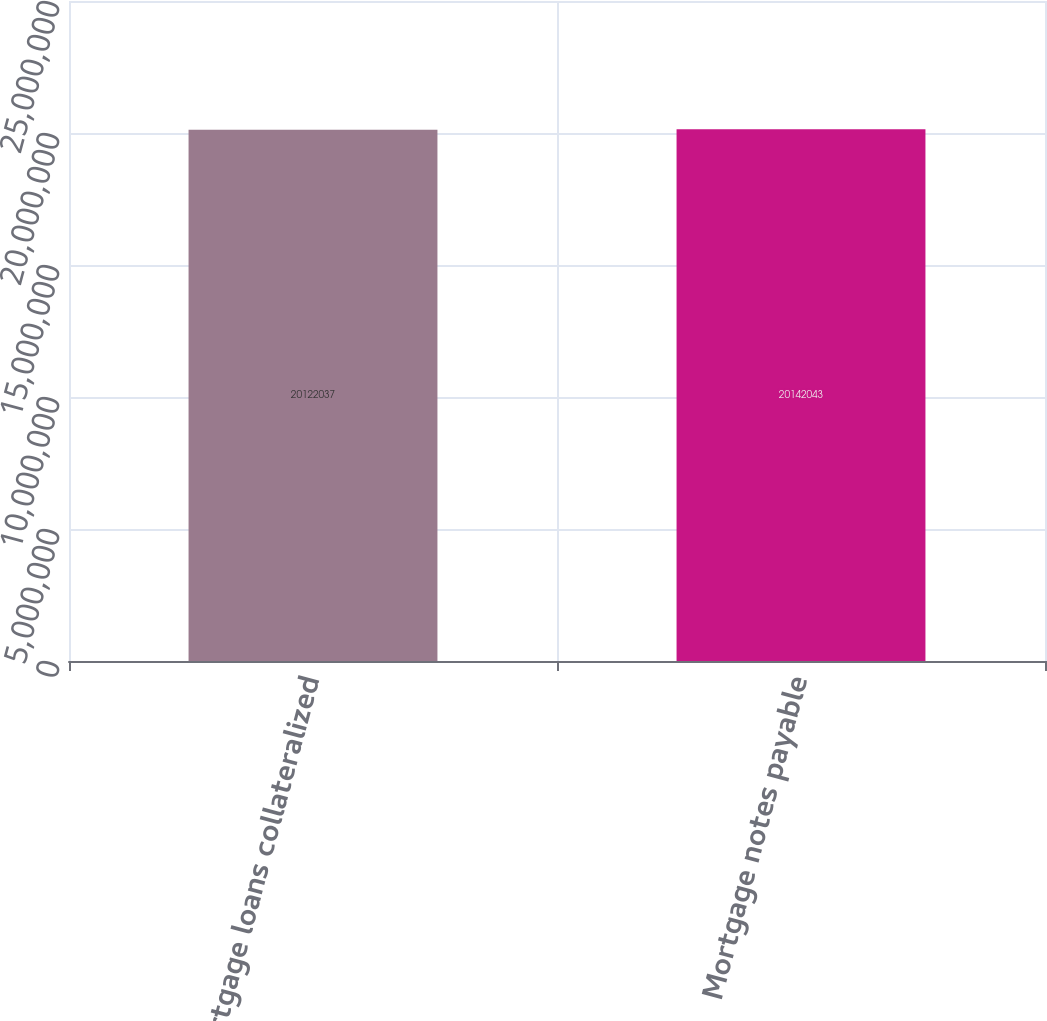<chart> <loc_0><loc_0><loc_500><loc_500><bar_chart><fcel>Mortgage loans collateralized<fcel>Mortgage notes payable<nl><fcel>2.0122e+07<fcel>2.0142e+07<nl></chart> 